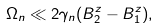<formula> <loc_0><loc_0><loc_500><loc_500>\Omega _ { n } \ll 2 \gamma _ { n } ( B _ { 2 } ^ { z } - B _ { 1 } ^ { z } ) ,</formula> 